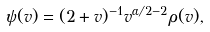<formula> <loc_0><loc_0><loc_500><loc_500>\psi ( v ) = ( 2 + v ) ^ { - 1 } v ^ { \alpha / 2 - 2 } \rho ( v ) ,</formula> 